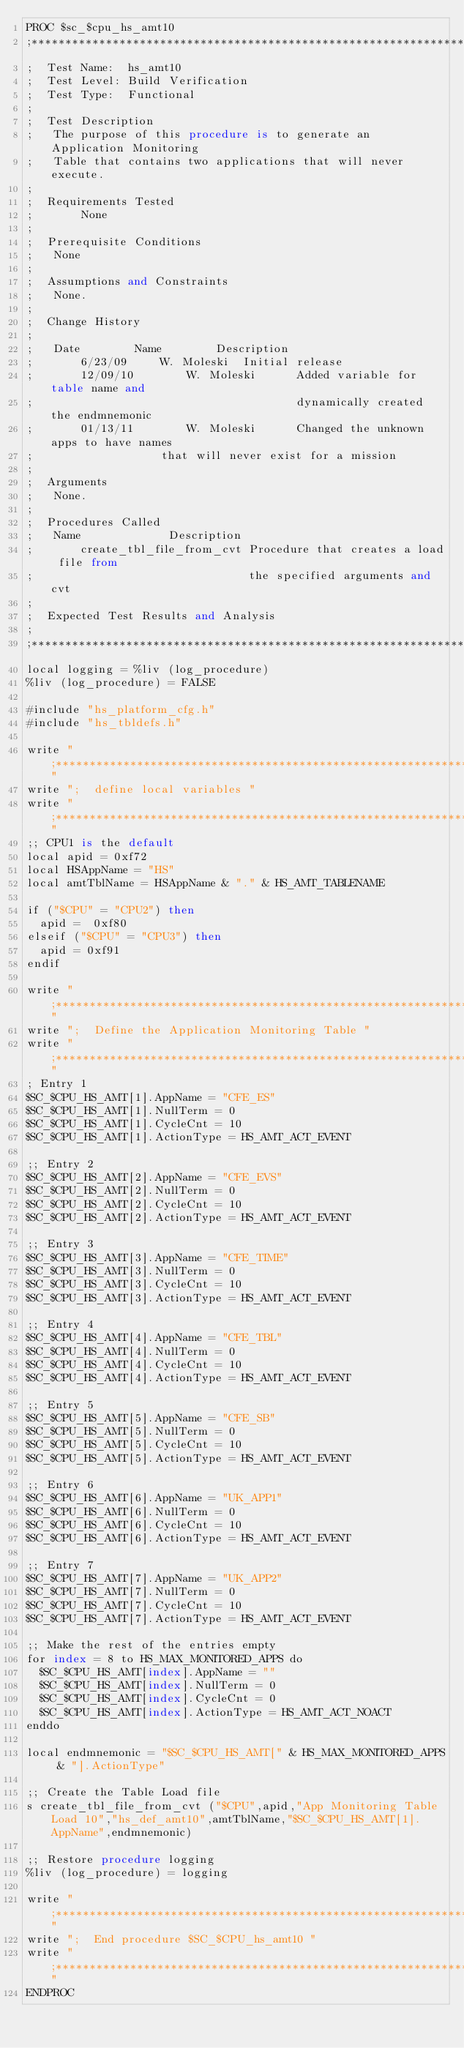<code> <loc_0><loc_0><loc_500><loc_500><_SQL_>PROC $sc_$cpu_hs_amt10
;*******************************************************************************
;  Test Name:  hs_amt10
;  Test Level: Build Verification
;  Test Type:  Functional
;
;  Test Description
;	The purpose of this procedure is to generate an Application Monitoring
;	Table that contains two applications that will never execute.
;
;  Requirements Tested
;       None
;
;  Prerequisite Conditions
;	None
;
;  Assumptions and Constraints
;	None.
;
;  Change History
;
;	Date		Name		Description
;       6/23/09		W. Moleski	Initial release
;       12/09/10        W. Moleski      Added variable for table name and
;                                       dynamically created the endmnemonic
;       01/13/11        W. Moleski      Changed the unknown apps to have names
;					that will never exist for a mission
;
;  Arguments
;	None.
;
;  Procedures Called
;	Name			 Description
;       create_tbl_file_from_cvt Procedure that creates a load file from
;                                the specified arguments and cvt
;
;  Expected Test Results and Analysis
;
;**********************************************************************
local logging = %liv (log_procedure)
%liv (log_procedure) = FALSE

#include "hs_platform_cfg.h"
#include "hs_tbldefs.h"

write ";*********************************************************************"
write ";  define local variables "
write ";*********************************************************************"
;; CPU1 is the default
local apid = 0xf72
local HSAppName = "HS"
local amtTblName = HSAppName & "." & HS_AMT_TABLENAME

if ("$CPU" = "CPU2") then
  apid =  0xf80
elseif ("$CPU" = "CPU3") then
  apid = 0xf91
endif 

write ";*********************************************************************"
write ";  Define the Application Monitoring Table "
write ";*********************************************************************"
; Entry 1
$SC_$CPU_HS_AMT[1].AppName = "CFE_ES"
$SC_$CPU_HS_AMT[1].NullTerm = 0
$SC_$CPU_HS_AMT[1].CycleCnt = 10
$SC_$CPU_HS_AMT[1].ActionType = HS_AMT_ACT_EVENT

;; Entry 2
$SC_$CPU_HS_AMT[2].AppName = "CFE_EVS"
$SC_$CPU_HS_AMT[2].NullTerm = 0
$SC_$CPU_HS_AMT[2].CycleCnt = 10
$SC_$CPU_HS_AMT[2].ActionType = HS_AMT_ACT_EVENT

;; Entry 3
$SC_$CPU_HS_AMT[3].AppName = "CFE_TIME"
$SC_$CPU_HS_AMT[3].NullTerm = 0
$SC_$CPU_HS_AMT[3].CycleCnt = 10
$SC_$CPU_HS_AMT[3].ActionType = HS_AMT_ACT_EVENT

;; Entry 4
$SC_$CPU_HS_AMT[4].AppName = "CFE_TBL"
$SC_$CPU_HS_AMT[4].NullTerm = 0
$SC_$CPU_HS_AMT[4].CycleCnt = 10
$SC_$CPU_HS_AMT[4].ActionType = HS_AMT_ACT_EVENT

;; Entry 5
$SC_$CPU_HS_AMT[5].AppName = "CFE_SB"
$SC_$CPU_HS_AMT[5].NullTerm = 0
$SC_$CPU_HS_AMT[5].CycleCnt = 10
$SC_$CPU_HS_AMT[5].ActionType = HS_AMT_ACT_EVENT

;; Entry 6
$SC_$CPU_HS_AMT[6].AppName = "UK_APP1"
$SC_$CPU_HS_AMT[6].NullTerm = 0
$SC_$CPU_HS_AMT[6].CycleCnt = 10
$SC_$CPU_HS_AMT[6].ActionType = HS_AMT_ACT_EVENT

;; Entry 7
$SC_$CPU_HS_AMT[7].AppName = "UK_APP2"
$SC_$CPU_HS_AMT[7].NullTerm = 0
$SC_$CPU_HS_AMT[7].CycleCnt = 10
$SC_$CPU_HS_AMT[7].ActionType = HS_AMT_ACT_EVENT

;; Make the rest of the entries empty
for index = 8 to HS_MAX_MONITORED_APPS do
  $SC_$CPU_HS_AMT[index].AppName = ""
  $SC_$CPU_HS_AMT[index].NullTerm = 0
  $SC_$CPU_HS_AMT[index].CycleCnt = 0
  $SC_$CPU_HS_AMT[index].ActionType = HS_AMT_ACT_NOACT
enddo

local endmnemonic = "$SC_$CPU_HS_AMT[" & HS_MAX_MONITORED_APPS & "].ActionType"

;; Create the Table Load file
s create_tbl_file_from_cvt ("$CPU",apid,"App Monitoring Table Load 10","hs_def_amt10",amtTblName,"$SC_$CPU_HS_AMT[1].AppName",endmnemonic)

;; Restore procedure logging
%liv (log_procedure) = logging

write ";*********************************************************************"
write ";  End procedure $SC_$CPU_hs_amt10 "
write ";*********************************************************************"
ENDPROC
</code> 